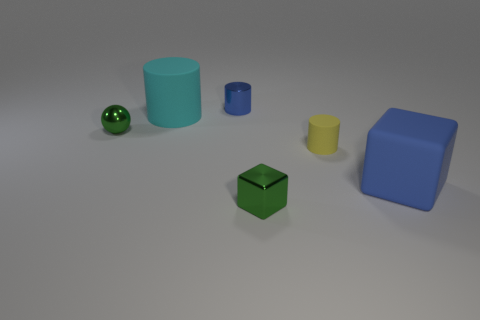Add 2 tiny blue matte spheres. How many objects exist? 8 Subtract all yellow cylinders. How many cylinders are left? 2 Subtract all yellow matte cylinders. How many cylinders are left? 2 Add 5 blue rubber cubes. How many blue rubber cubes are left? 6 Add 5 small green cubes. How many small green cubes exist? 6 Subtract 1 yellow cylinders. How many objects are left? 5 Subtract all cubes. How many objects are left? 4 Subtract 1 cylinders. How many cylinders are left? 2 Subtract all brown blocks. Subtract all cyan cylinders. How many blocks are left? 2 Subtract all red balls. How many cyan cylinders are left? 1 